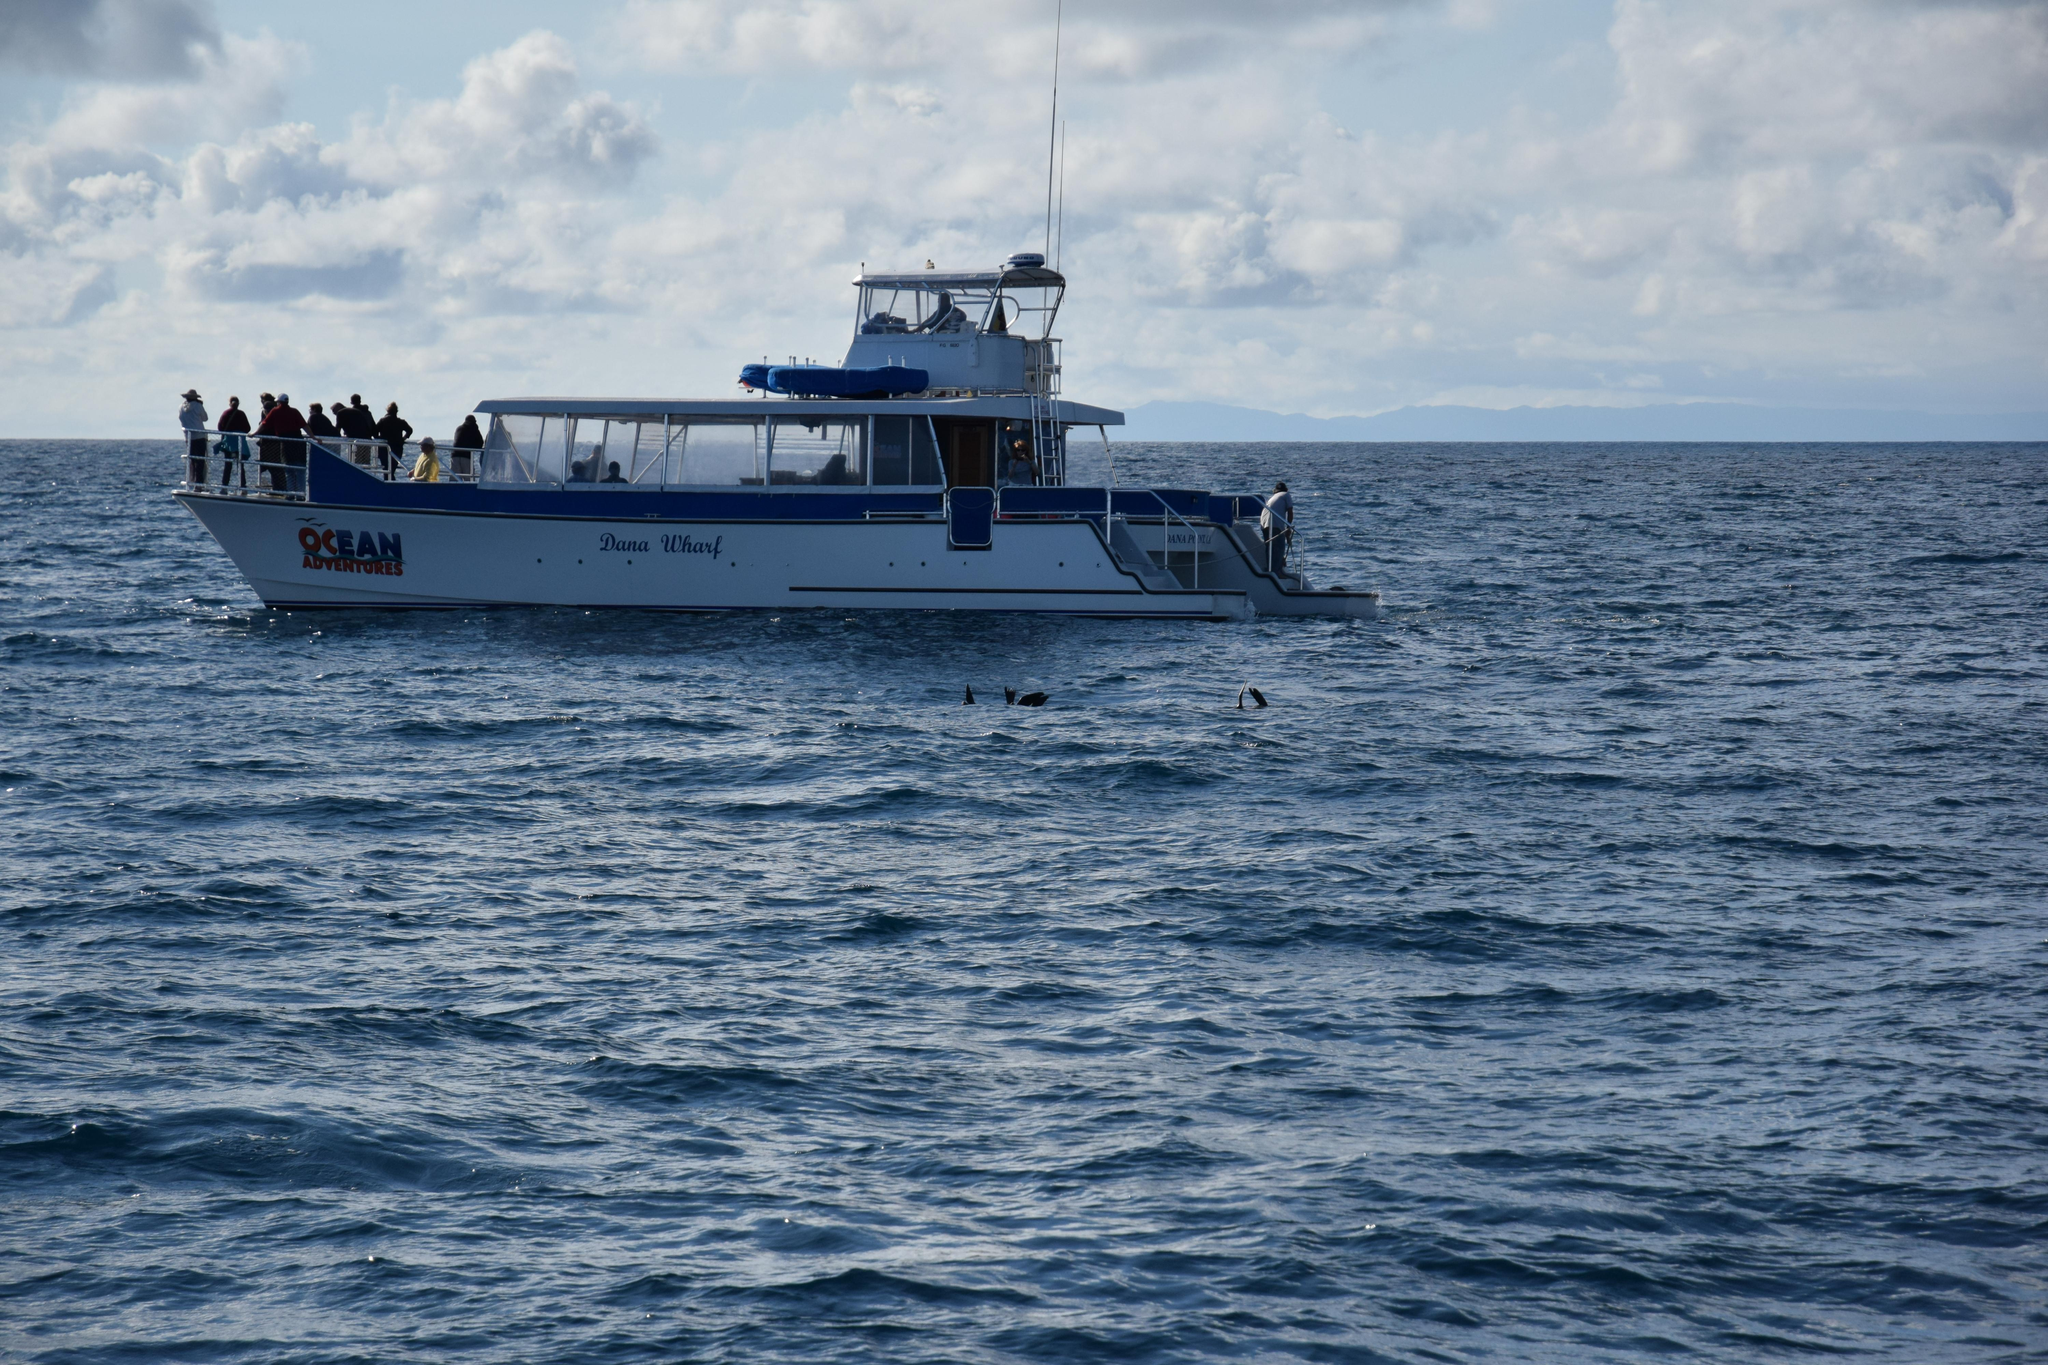Who is present in the image? There are people in the image. What are the people doing in the image? The people are sailing a boat. Where is the boat located in the image? The boat is on the water. What can be seen in the background of the image? The background of the image includes a cloudy sky. How many legs does the canvas have in the image? There is no canvas present in the image, and therefore no legs can be attributed to it. 